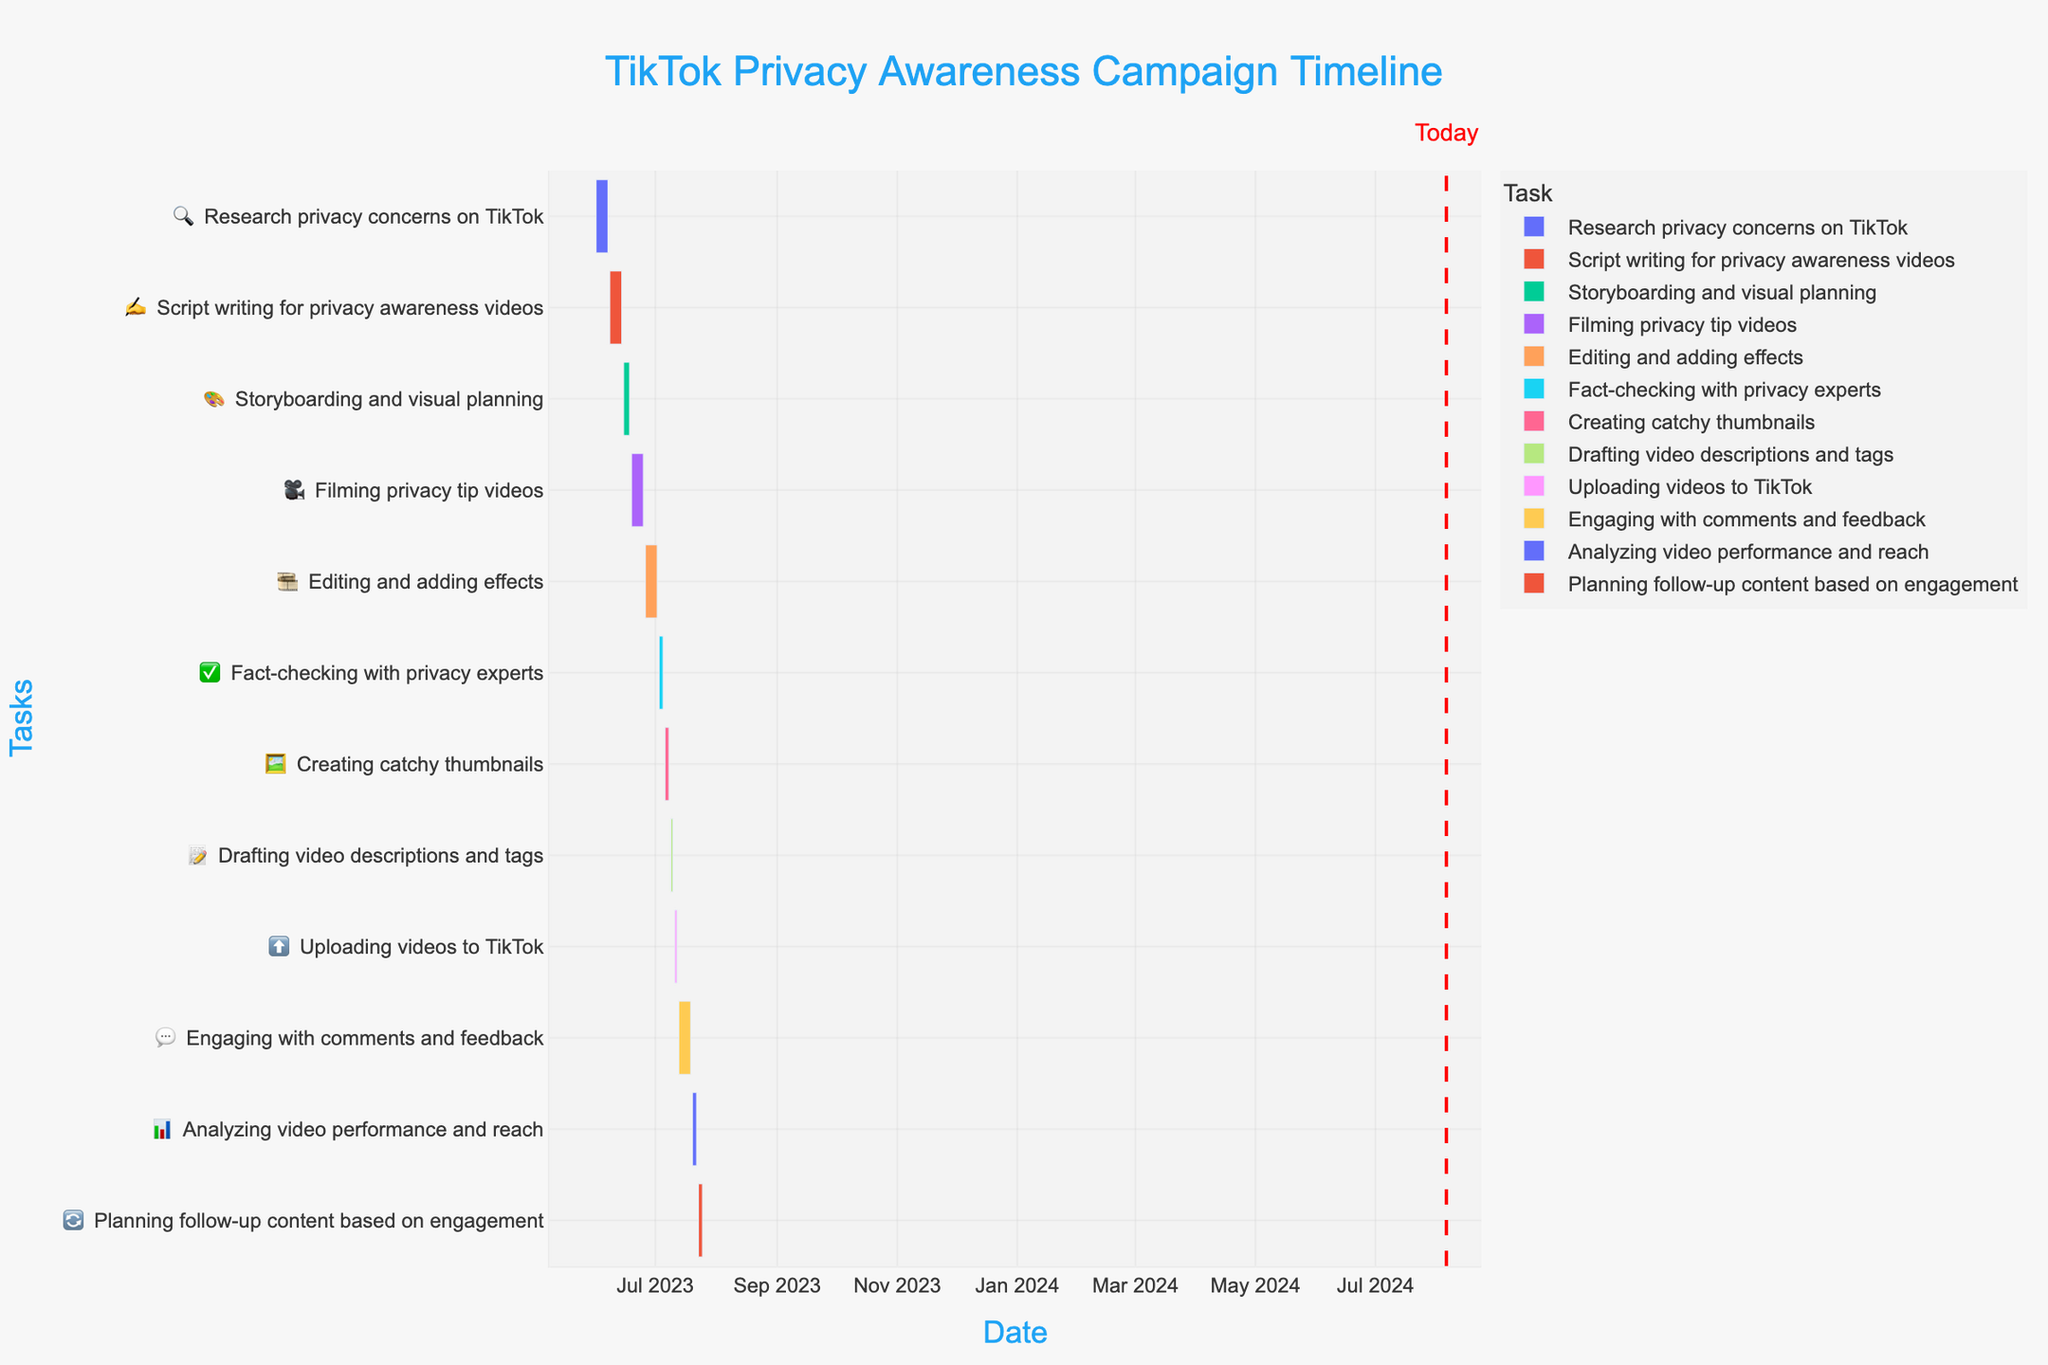What is the title of the Gantt Chart? The title of the Gantt Chart is displayed prominently at the top of the chart. It summarizes the content of the chart.
Answer: TikTok Privacy Awareness Campaign Timeline What task starts immediately after "Script writing for privacy awareness videos"? Look at the task bars on the timeline and check which task follows directly after the "Script writing for privacy awareness videos" task.
Answer: Storyboarding and visual planning Which task takes the longest time to complete? Compare the duration of each task by observing the length of the bars in the Gantt Chart. The longest bar represents the task with the longest duration.
Answer: Engaging with comments and feedback Which task was completed on July 8, 2023? Locate the date July 8, 2023 on the timeline axis and identify the task bar that ends on this date.
Answer: Creating catchy thumbnails What is the total duration of the "Editing and adding effects" task in days? Look at the start and end dates of the "Editing and adding effects" task and calculate the number of days between them.
Answer: 7 days How many tasks are completed before July starts? Identify tasks with end dates before July 1, 2023, and count them.
Answer: 4 tasks Which task ends immediately before "Uploading videos to TikTok"? Find the task that is finished just prior to the start of the "Uploading videos to TikTok" task on the timeline.
Answer: Drafting video descriptions and tags Compare the duration of "Research privacy concerns on TikTok" and "Fact-checking with privacy experts". Which one is longer and by how many days? Calculate the duration of both tasks by subtracting their start dates from their end dates. Compare the two durations and find the difference.
Answer: Research privacy concerns on TikTok is longer by 4 days (6 days vs. 2 days) What is the average duration in days of all the tasks? Calculate the duration of each task in days, sum them, and then divide by the number of tasks.
Answer: 6 days 